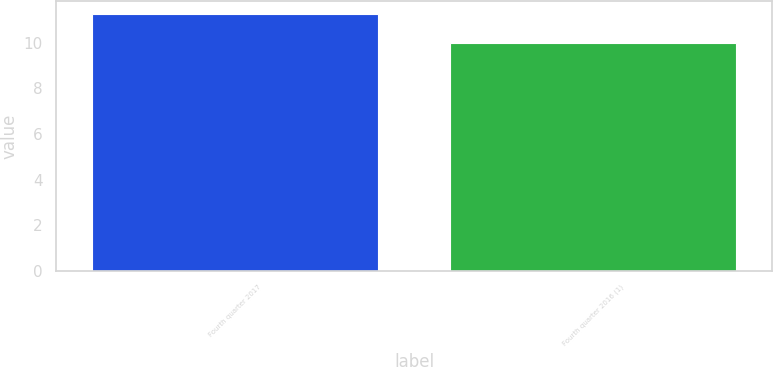Convert chart to OTSL. <chart><loc_0><loc_0><loc_500><loc_500><bar_chart><fcel>Fourth quarter 2017<fcel>Fourth quarter 2016 (1)<nl><fcel>11.25<fcel>10<nl></chart> 